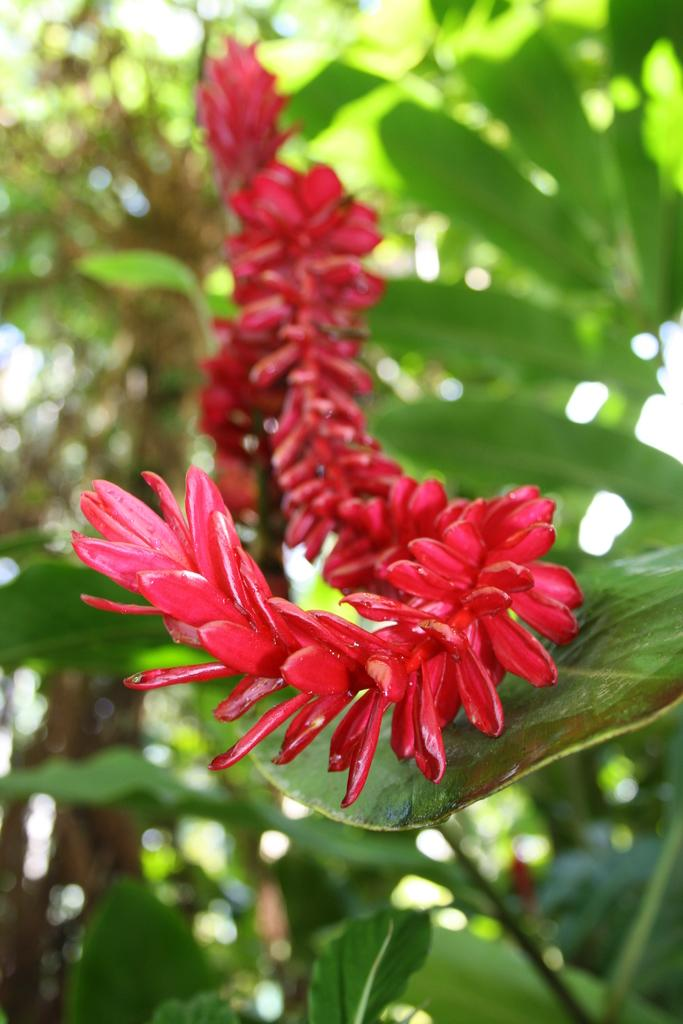What type of living organisms can be seen in the image? There are flowers in the image. Where are the flowers located? The flowers are on plants. What color are the flowers? The flowers are red in color. Can you describe the background of the image? The background is blurred. What type of prose is being recited by the flowers in the image? There is no indication in the image that the flowers are reciting any prose, as flowers do not have the ability to speak or recite literature. 